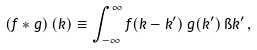Convert formula to latex. <formula><loc_0><loc_0><loc_500><loc_500>\left ( f * g \right ) ( { k } ) \equiv \int ^ { \infty } _ { - \infty } f ( { k } - { k ^ { \prime } } ) \, g ( { k ^ { \prime } } ) \, \i k ^ { \prime } \, ,</formula> 